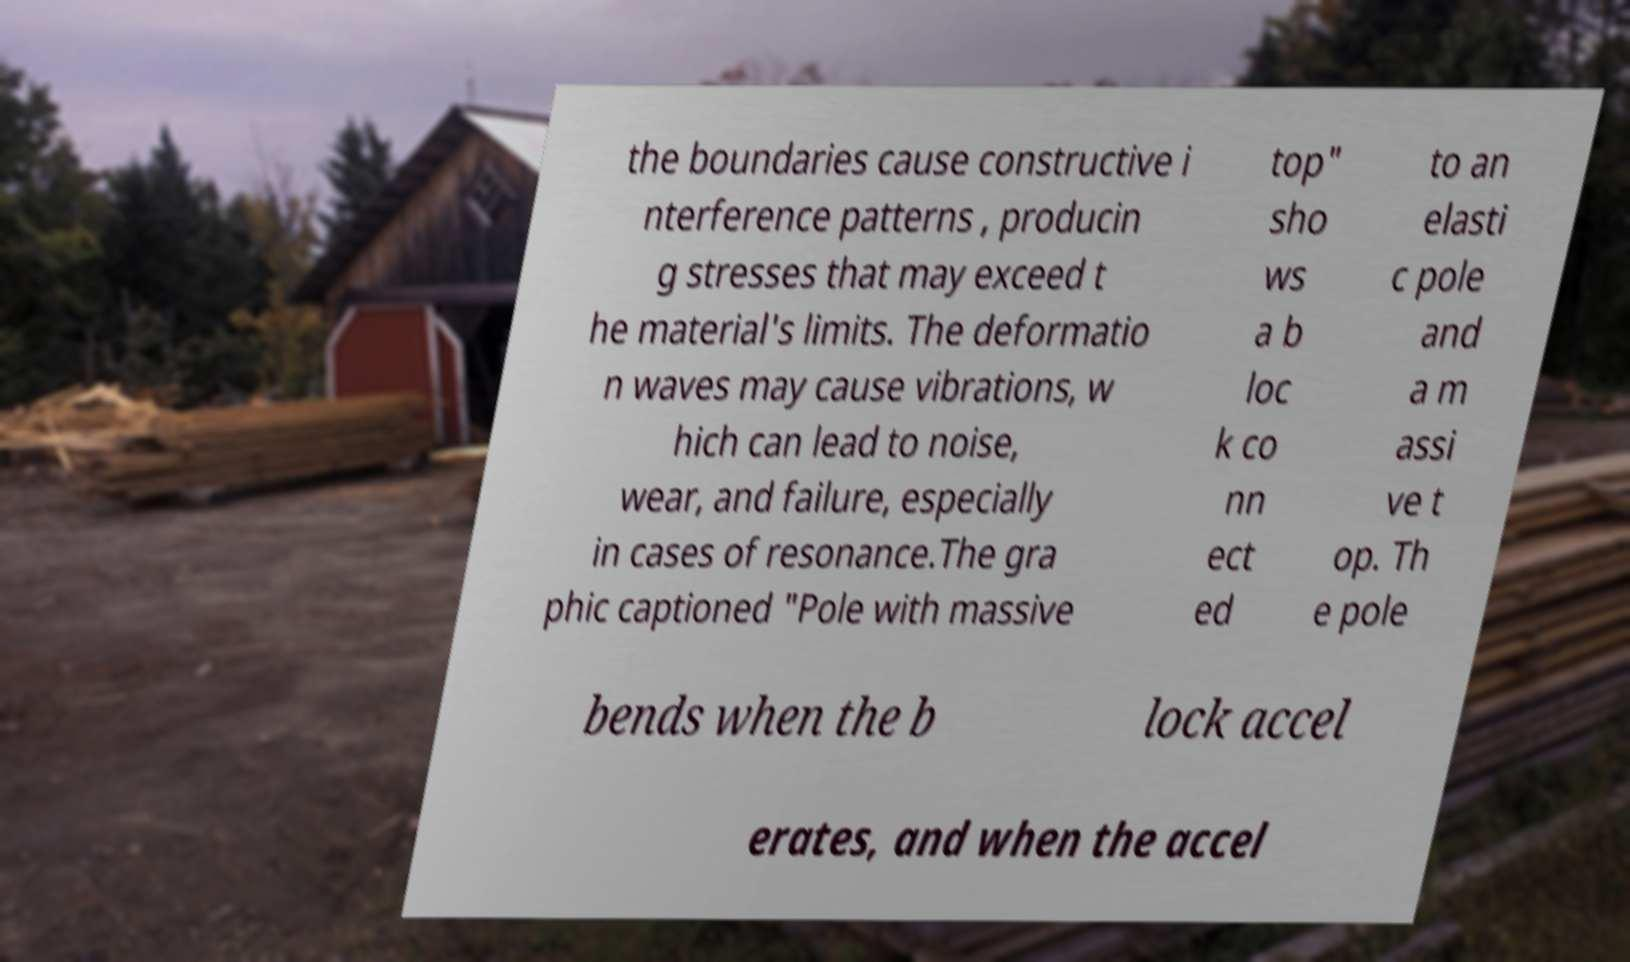Please identify and transcribe the text found in this image. the boundaries cause constructive i nterference patterns , producin g stresses that may exceed t he material's limits. The deformatio n waves may cause vibrations, w hich can lead to noise, wear, and failure, especially in cases of resonance.The gra phic captioned "Pole with massive top" sho ws a b loc k co nn ect ed to an elasti c pole and a m assi ve t op. Th e pole bends when the b lock accel erates, and when the accel 